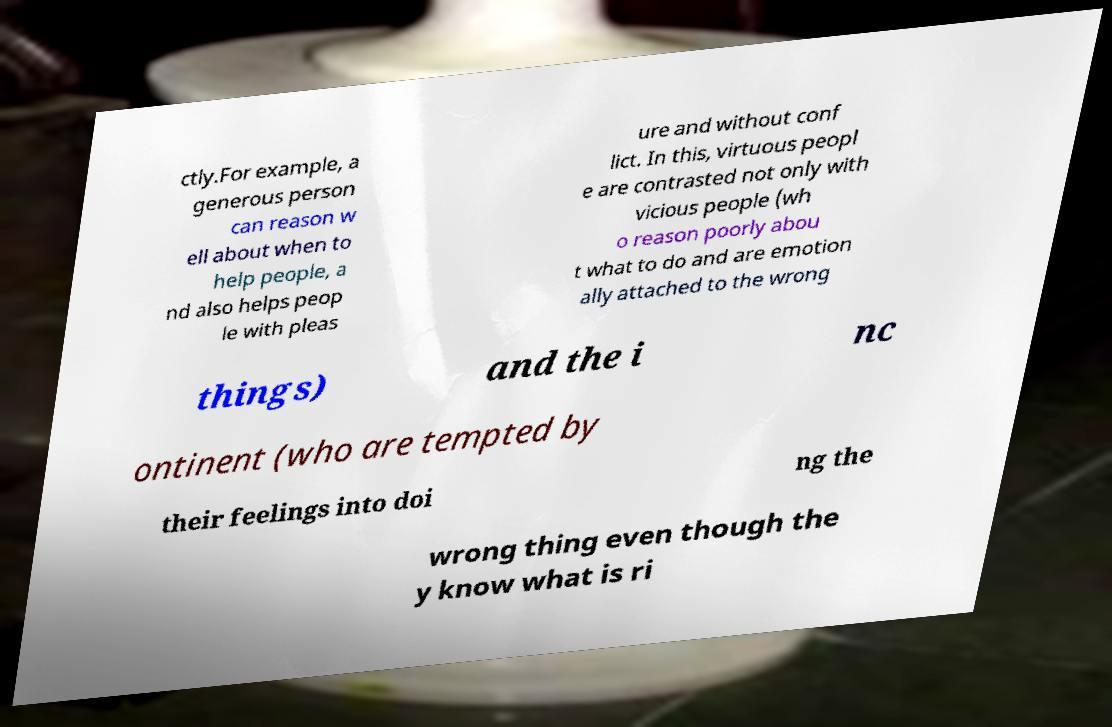For documentation purposes, I need the text within this image transcribed. Could you provide that? ctly.For example, a generous person can reason w ell about when to help people, a nd also helps peop le with pleas ure and without conf lict. In this, virtuous peopl e are contrasted not only with vicious people (wh o reason poorly abou t what to do and are emotion ally attached to the wrong things) and the i nc ontinent (who are tempted by their feelings into doi ng the wrong thing even though the y know what is ri 